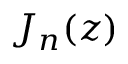<formula> <loc_0><loc_0><loc_500><loc_500>J _ { n } ( z )</formula> 